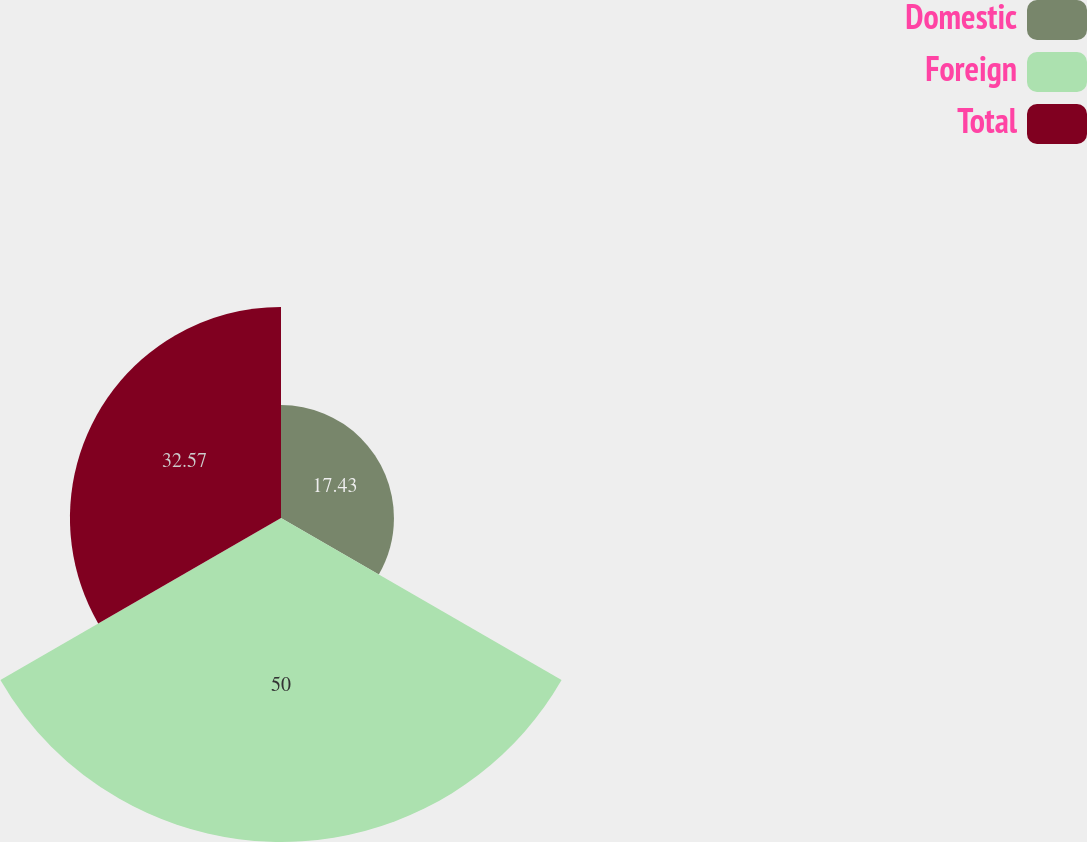<chart> <loc_0><loc_0><loc_500><loc_500><pie_chart><fcel>Domestic<fcel>Foreign<fcel>Total<nl><fcel>17.43%<fcel>50.0%<fcel>32.57%<nl></chart> 